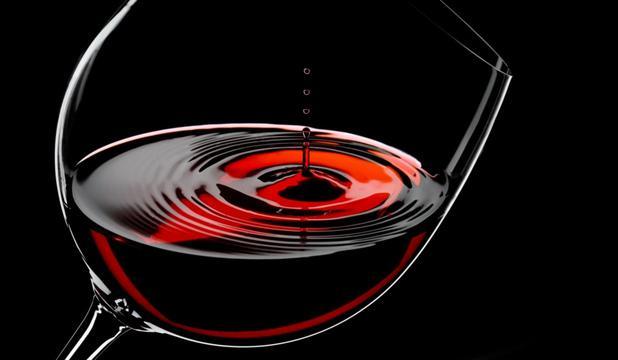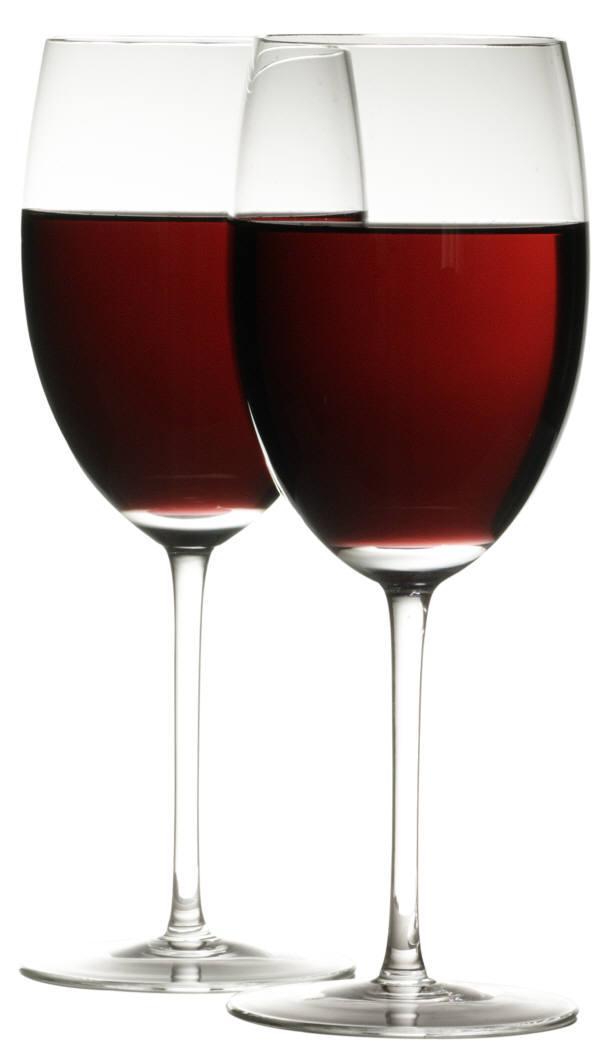The first image is the image on the left, the second image is the image on the right. Given the left and right images, does the statement "A pair of clinking wine glasses create a splash of wine that reaches above the rim of the glass." hold true? Answer yes or no. No. The first image is the image on the left, the second image is the image on the right. Given the left and right images, does the statement "The right image contains two wine glasses with red wine in them." hold true? Answer yes or no. Yes. 